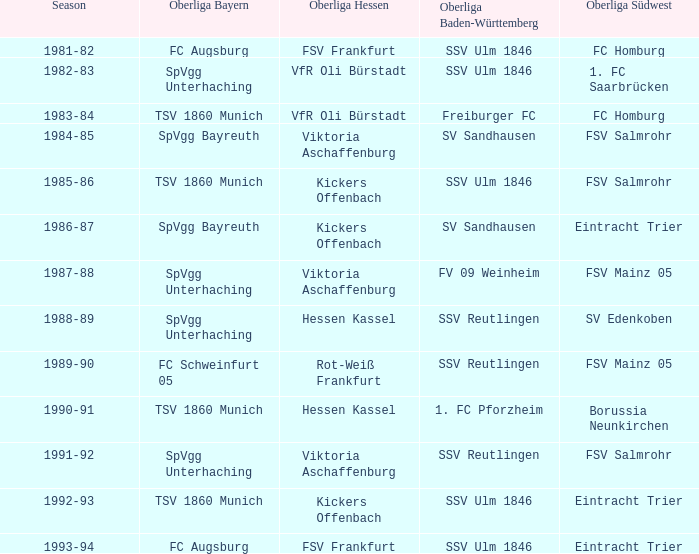Which oberliga südwest league is associated with the oberliga bayern of fc schweinfurt 05? FSV Mainz 05. 